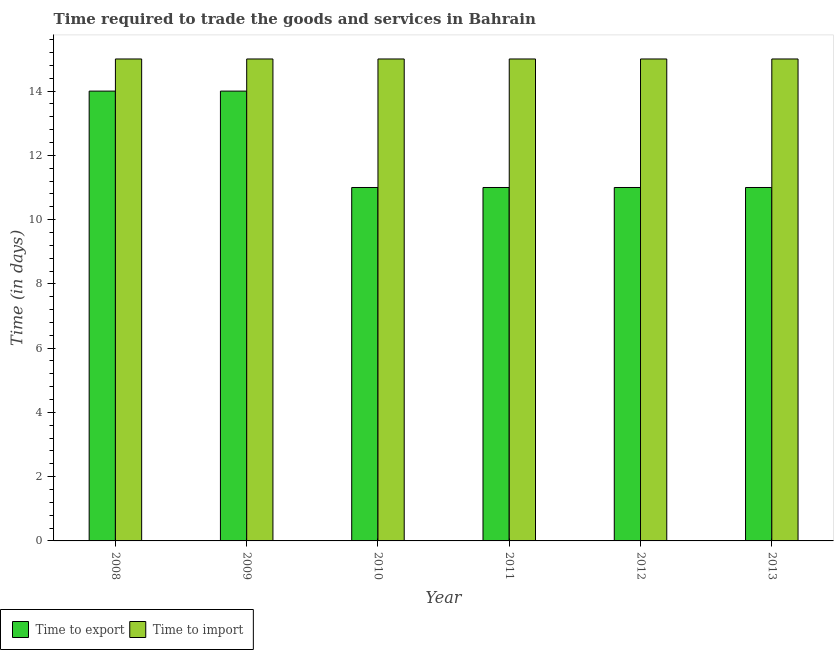How many bars are there on the 6th tick from the left?
Make the answer very short. 2. How many bars are there on the 6th tick from the right?
Keep it short and to the point. 2. What is the time to export in 2013?
Ensure brevity in your answer.  11. Across all years, what is the maximum time to export?
Make the answer very short. 14. Across all years, what is the minimum time to import?
Keep it short and to the point. 15. In which year was the time to export minimum?
Make the answer very short. 2010. What is the total time to import in the graph?
Offer a very short reply. 90. What is the difference between the time to import in 2009 and that in 2012?
Give a very brief answer. 0. What is the average time to import per year?
Your response must be concise. 15. In the year 2012, what is the difference between the time to export and time to import?
Provide a short and direct response. 0. In how many years, is the time to export greater than 6 days?
Your response must be concise. 6. What is the ratio of the time to export in 2008 to that in 2012?
Offer a very short reply. 1.27. Is the difference between the time to import in 2012 and 2013 greater than the difference between the time to export in 2012 and 2013?
Keep it short and to the point. No. What is the difference between the highest and the second highest time to import?
Ensure brevity in your answer.  0. What is the difference between the highest and the lowest time to export?
Your answer should be compact. 3. In how many years, is the time to export greater than the average time to export taken over all years?
Give a very brief answer. 2. What does the 1st bar from the left in 2012 represents?
Your answer should be compact. Time to export. What does the 1st bar from the right in 2008 represents?
Offer a terse response. Time to import. How many bars are there?
Offer a terse response. 12. How many years are there in the graph?
Provide a succinct answer. 6. Does the graph contain any zero values?
Ensure brevity in your answer.  No. Does the graph contain grids?
Offer a very short reply. No. What is the title of the graph?
Keep it short and to the point. Time required to trade the goods and services in Bahrain. Does "Lower secondary education" appear as one of the legend labels in the graph?
Your answer should be very brief. No. What is the label or title of the X-axis?
Provide a short and direct response. Year. What is the label or title of the Y-axis?
Your answer should be compact. Time (in days). What is the Time (in days) of Time to export in 2009?
Keep it short and to the point. 14. What is the Time (in days) in Time to import in 2009?
Provide a short and direct response. 15. What is the Time (in days) of Time to export in 2010?
Your answer should be compact. 11. What is the Time (in days) of Time to import in 2010?
Keep it short and to the point. 15. What is the Time (in days) in Time to import in 2011?
Your answer should be compact. 15. What is the Time (in days) in Time to export in 2013?
Give a very brief answer. 11. What is the Time (in days) of Time to import in 2013?
Provide a succinct answer. 15. Across all years, what is the maximum Time (in days) of Time to import?
Give a very brief answer. 15. Across all years, what is the minimum Time (in days) in Time to export?
Ensure brevity in your answer.  11. Across all years, what is the minimum Time (in days) in Time to import?
Your answer should be very brief. 15. What is the total Time (in days) in Time to export in the graph?
Provide a succinct answer. 72. What is the difference between the Time (in days) of Time to export in 2008 and that in 2010?
Give a very brief answer. 3. What is the difference between the Time (in days) in Time to import in 2008 and that in 2010?
Your response must be concise. 0. What is the difference between the Time (in days) in Time to import in 2008 and that in 2011?
Give a very brief answer. 0. What is the difference between the Time (in days) in Time to import in 2008 and that in 2012?
Keep it short and to the point. 0. What is the difference between the Time (in days) of Time to export in 2008 and that in 2013?
Provide a succinct answer. 3. What is the difference between the Time (in days) in Time to import in 2008 and that in 2013?
Your answer should be compact. 0. What is the difference between the Time (in days) in Time to export in 2009 and that in 2010?
Make the answer very short. 3. What is the difference between the Time (in days) of Time to export in 2009 and that in 2011?
Keep it short and to the point. 3. What is the difference between the Time (in days) in Time to import in 2009 and that in 2011?
Keep it short and to the point. 0. What is the difference between the Time (in days) in Time to import in 2009 and that in 2012?
Your response must be concise. 0. What is the difference between the Time (in days) of Time to export in 2010 and that in 2011?
Offer a very short reply. 0. What is the difference between the Time (in days) of Time to import in 2010 and that in 2011?
Provide a short and direct response. 0. What is the difference between the Time (in days) in Time to import in 2010 and that in 2012?
Make the answer very short. 0. What is the difference between the Time (in days) in Time to export in 2010 and that in 2013?
Give a very brief answer. 0. What is the difference between the Time (in days) in Time to export in 2011 and that in 2012?
Make the answer very short. 0. What is the difference between the Time (in days) of Time to import in 2011 and that in 2012?
Offer a very short reply. 0. What is the difference between the Time (in days) in Time to import in 2012 and that in 2013?
Ensure brevity in your answer.  0. What is the difference between the Time (in days) in Time to export in 2008 and the Time (in days) in Time to import in 2009?
Provide a short and direct response. -1. What is the difference between the Time (in days) in Time to export in 2008 and the Time (in days) in Time to import in 2012?
Offer a terse response. -1. What is the difference between the Time (in days) of Time to export in 2009 and the Time (in days) of Time to import in 2010?
Your response must be concise. -1. What is the difference between the Time (in days) in Time to export in 2009 and the Time (in days) in Time to import in 2011?
Provide a succinct answer. -1. What is the difference between the Time (in days) in Time to export in 2009 and the Time (in days) in Time to import in 2013?
Provide a succinct answer. -1. What is the difference between the Time (in days) in Time to export in 2010 and the Time (in days) in Time to import in 2011?
Offer a terse response. -4. What is the difference between the Time (in days) in Time to export in 2010 and the Time (in days) in Time to import in 2013?
Give a very brief answer. -4. What is the difference between the Time (in days) of Time to export in 2012 and the Time (in days) of Time to import in 2013?
Ensure brevity in your answer.  -4. What is the average Time (in days) in Time to export per year?
Offer a very short reply. 12. What is the average Time (in days) in Time to import per year?
Make the answer very short. 15. In the year 2008, what is the difference between the Time (in days) of Time to export and Time (in days) of Time to import?
Provide a succinct answer. -1. In the year 2009, what is the difference between the Time (in days) in Time to export and Time (in days) in Time to import?
Your answer should be compact. -1. In the year 2012, what is the difference between the Time (in days) of Time to export and Time (in days) of Time to import?
Keep it short and to the point. -4. What is the ratio of the Time (in days) in Time to import in 2008 to that in 2009?
Your answer should be very brief. 1. What is the ratio of the Time (in days) in Time to export in 2008 to that in 2010?
Keep it short and to the point. 1.27. What is the ratio of the Time (in days) of Time to import in 2008 to that in 2010?
Keep it short and to the point. 1. What is the ratio of the Time (in days) in Time to export in 2008 to that in 2011?
Give a very brief answer. 1.27. What is the ratio of the Time (in days) in Time to import in 2008 to that in 2011?
Offer a very short reply. 1. What is the ratio of the Time (in days) in Time to export in 2008 to that in 2012?
Make the answer very short. 1.27. What is the ratio of the Time (in days) of Time to import in 2008 to that in 2012?
Provide a succinct answer. 1. What is the ratio of the Time (in days) in Time to export in 2008 to that in 2013?
Your answer should be very brief. 1.27. What is the ratio of the Time (in days) of Time to export in 2009 to that in 2010?
Keep it short and to the point. 1.27. What is the ratio of the Time (in days) of Time to import in 2009 to that in 2010?
Offer a very short reply. 1. What is the ratio of the Time (in days) in Time to export in 2009 to that in 2011?
Your answer should be compact. 1.27. What is the ratio of the Time (in days) of Time to import in 2009 to that in 2011?
Make the answer very short. 1. What is the ratio of the Time (in days) in Time to export in 2009 to that in 2012?
Make the answer very short. 1.27. What is the ratio of the Time (in days) of Time to export in 2009 to that in 2013?
Provide a succinct answer. 1.27. What is the ratio of the Time (in days) in Time to import in 2009 to that in 2013?
Provide a short and direct response. 1. What is the ratio of the Time (in days) in Time to export in 2010 to that in 2011?
Your answer should be compact. 1. What is the ratio of the Time (in days) in Time to import in 2010 to that in 2011?
Your answer should be compact. 1. What is the ratio of the Time (in days) in Time to import in 2010 to that in 2013?
Give a very brief answer. 1. What is the ratio of the Time (in days) in Time to export in 2011 to that in 2012?
Your answer should be very brief. 1. What is the ratio of the Time (in days) in Time to import in 2011 to that in 2012?
Provide a succinct answer. 1. What is the ratio of the Time (in days) in Time to export in 2011 to that in 2013?
Keep it short and to the point. 1. What is the ratio of the Time (in days) of Time to import in 2011 to that in 2013?
Provide a succinct answer. 1. What is the ratio of the Time (in days) of Time to export in 2012 to that in 2013?
Give a very brief answer. 1. What is the ratio of the Time (in days) of Time to import in 2012 to that in 2013?
Give a very brief answer. 1. What is the difference between the highest and the lowest Time (in days) of Time to export?
Give a very brief answer. 3. What is the difference between the highest and the lowest Time (in days) of Time to import?
Your response must be concise. 0. 